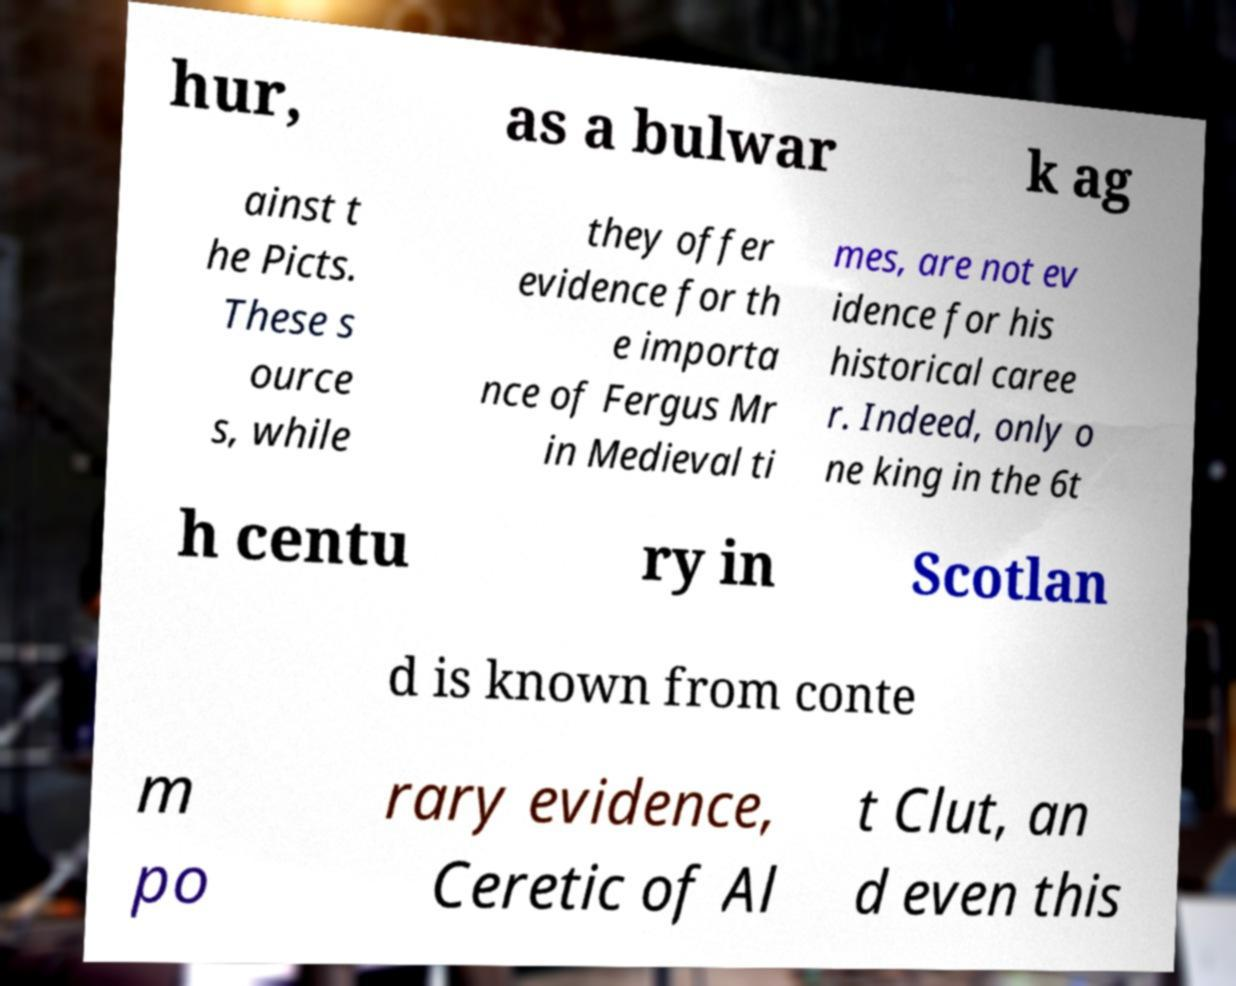Please identify and transcribe the text found in this image. hur, as a bulwar k ag ainst t he Picts. These s ource s, while they offer evidence for th e importa nce of Fergus Mr in Medieval ti mes, are not ev idence for his historical caree r. Indeed, only o ne king in the 6t h centu ry in Scotlan d is known from conte m po rary evidence, Ceretic of Al t Clut, an d even this 